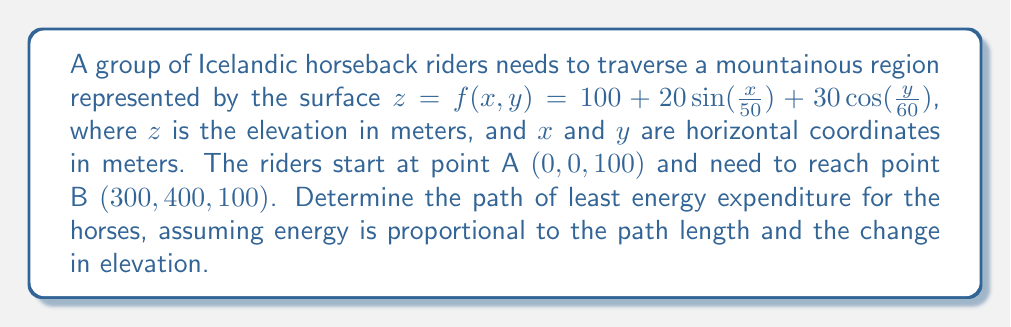What is the answer to this math problem? To find the optimal path, we need to minimize the energy functional, which is a combination of path length and elevation change. Let's approach this step-by-step:

1) The energy functional can be represented as:

   $$E = \int_0^L \left(1 + k\left|\frac{dz}{ds}\right|\right) ds$$

   where $s$ is the arc length, $L$ is the total path length, and $k$ is a constant representing the relative importance of elevation change.

2) Using the surface equation, we can express $dz$ in terms of $dx$ and $dy$:

   $$dz = \frac{\partial f}{\partial x}dx + \frac{\partial f}{\partial y}dy$$

   $$\frac{\partial f}{\partial x} = \frac{2}{5}\cos(\frac{x}{50})$$
   $$\frac{\partial f}{\partial y} = -\frac{1}{2}\sin(\frac{y}{60})$$

3) The arc length element is:

   $$ds = \sqrt{dx^2 + dy^2 + dz^2}$$

4) Substituting these into the energy functional:

   $$E = \int_0^L \left(1 + k\left|\frac{2}{5}\cos(\frac{x}{50})dx - \frac{1}{2}\sin(\frac{y}{60})dy\right|\right)\sqrt{1 + \left(\frac{2}{5}\cos(\frac{x}{50})\right)^2 + \left(-\frac{1}{2}\sin(\frac{y}{60})\right)^2} ds$$

5) To minimize this functional, we need to solve the Euler-Lagrange equations:

   $$\frac{\partial L}{\partial x} - \frac{d}{ds}\left(\frac{\partial L}{\partial x'}\right) = 0$$
   $$\frac{\partial L}{\partial y} - \frac{d}{ds}\left(\frac{\partial L}{\partial y'}\right) = 0$$

   where $L$ is the integrand of the energy functional.

6) Solving these equations analytically is extremely complex. In practice, numerical methods such as gradient descent or dynamic programming would be used to find the optimal path.

7) The solution would be a curve $(x(s), y(s))$ from $(0, 0)$ to $(300, 400)$ that minimizes the energy functional.

8) This path would generally avoid steep climbs and descents, favoring gradual changes in elevation while also considering the total distance traveled.
Answer: The optimal path is a curve $(x(s), y(s))$ from $(0, 0)$ to $(300, 400)$ that minimizes $\int_0^L \left(1 + k\left|\frac{2}{5}\cos(\frac{x}{50})dx - \frac{1}{2}\sin(\frac{y}{60})dy\right|\right)\sqrt{1 + \left(\frac{2}{5}\cos(\frac{x}{50})\right)^2 + \left(-\frac{1}{2}\sin(\frac{y}{60})\right)^2} ds$, found through numerical methods. 